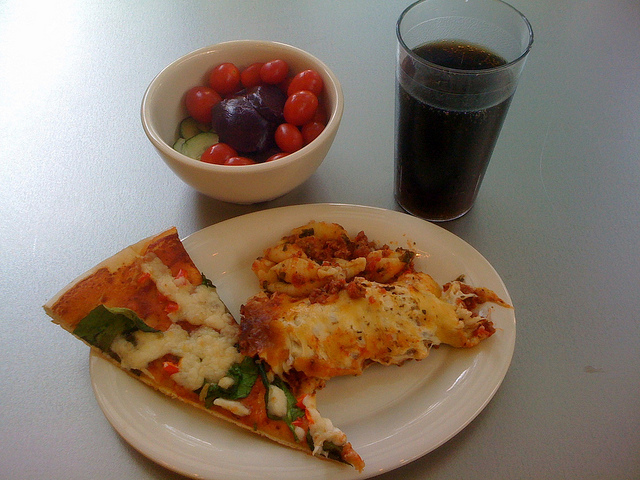<image>What fruit is in the bowl? It is unknown what fruit is in the bowl. It could be tomatoes or grapes. Which pizza is round? It is ambiguous as to which pizza is round. No clear answer can be given. What is the fruit that is next to the pizza? I am not sure what fruit is next to the pizza. It could be grape, tomato, or cherry. Or there might not be any fruit next to the pizza. What fruit is in the bowl? I don't know what fruit is in the bowl. It could be tomatoes or grapes. Which pizza is round? I don't know which pizza is round. Based on the given answers, it is not clear which one is round. What is the fruit that is next to the pizza? I am not sure what fruit is next to the pizza. It can be seen tomatoes or cherry. 